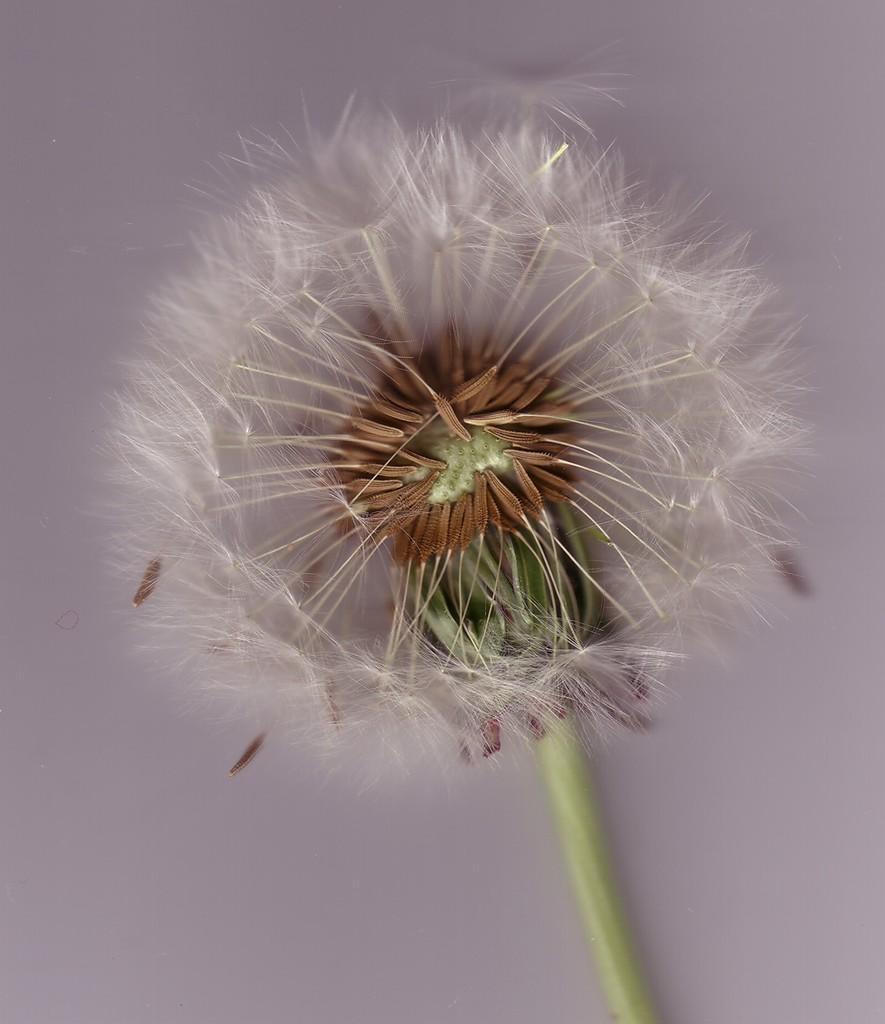How would you summarize this image in a sentence or two? In this image there is a flower with seeds and a stem. 